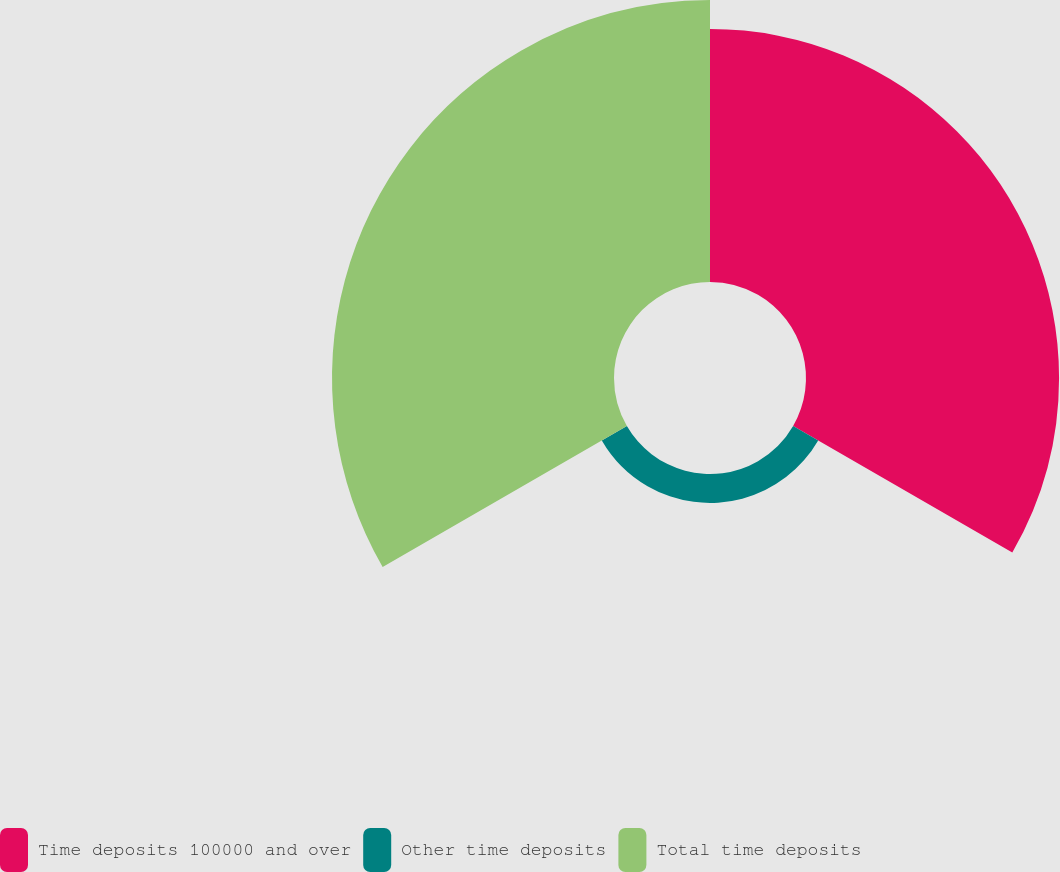<chart> <loc_0><loc_0><loc_500><loc_500><pie_chart><fcel>Time deposits 100000 and over<fcel>Other time deposits<fcel>Total time deposits<nl><fcel>44.87%<fcel>5.13%<fcel>50.0%<nl></chart> 